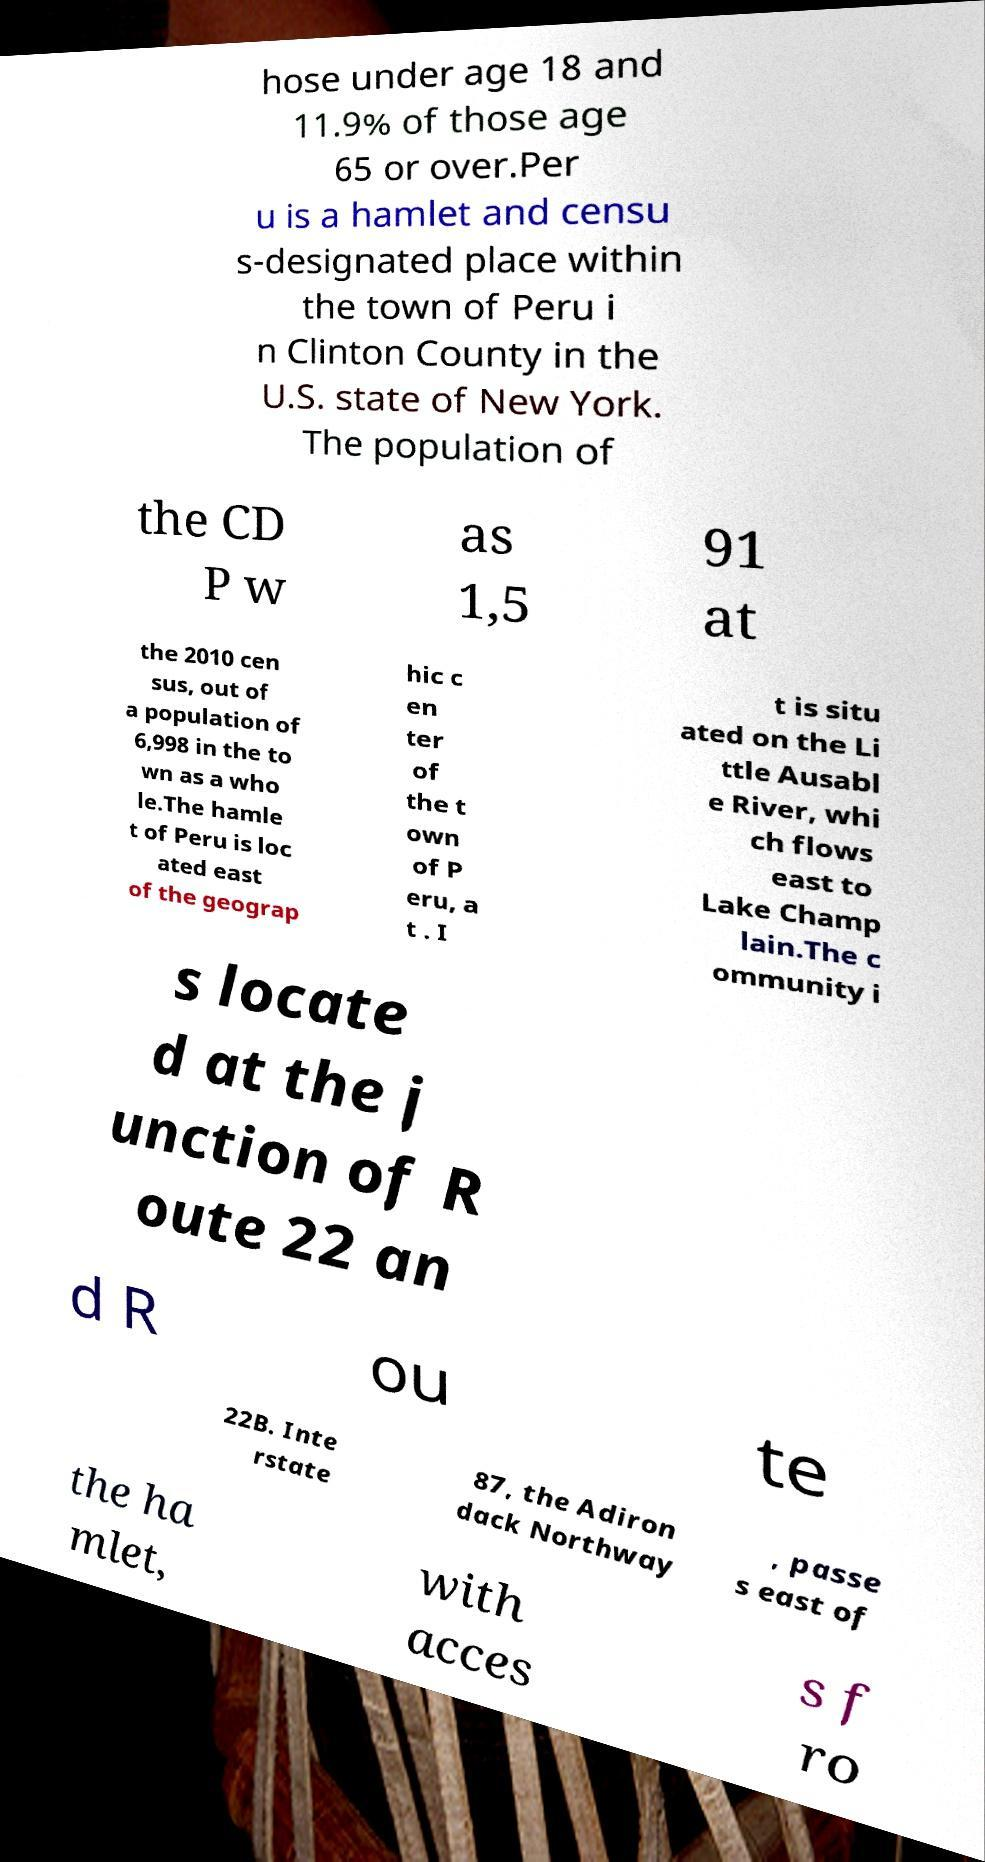There's text embedded in this image that I need extracted. Can you transcribe it verbatim? hose under age 18 and 11.9% of those age 65 or over.Per u is a hamlet and censu s-designated place within the town of Peru i n Clinton County in the U.S. state of New York. The population of the CD P w as 1,5 91 at the 2010 cen sus, out of a population of 6,998 in the to wn as a who le.The hamle t of Peru is loc ated east of the geograp hic c en ter of the t own of P eru, a t . I t is situ ated on the Li ttle Ausabl e River, whi ch flows east to Lake Champ lain.The c ommunity i s locate d at the j unction of R oute 22 an d R ou te 22B. Inte rstate 87, the Adiron dack Northway , passe s east of the ha mlet, with acces s f ro 